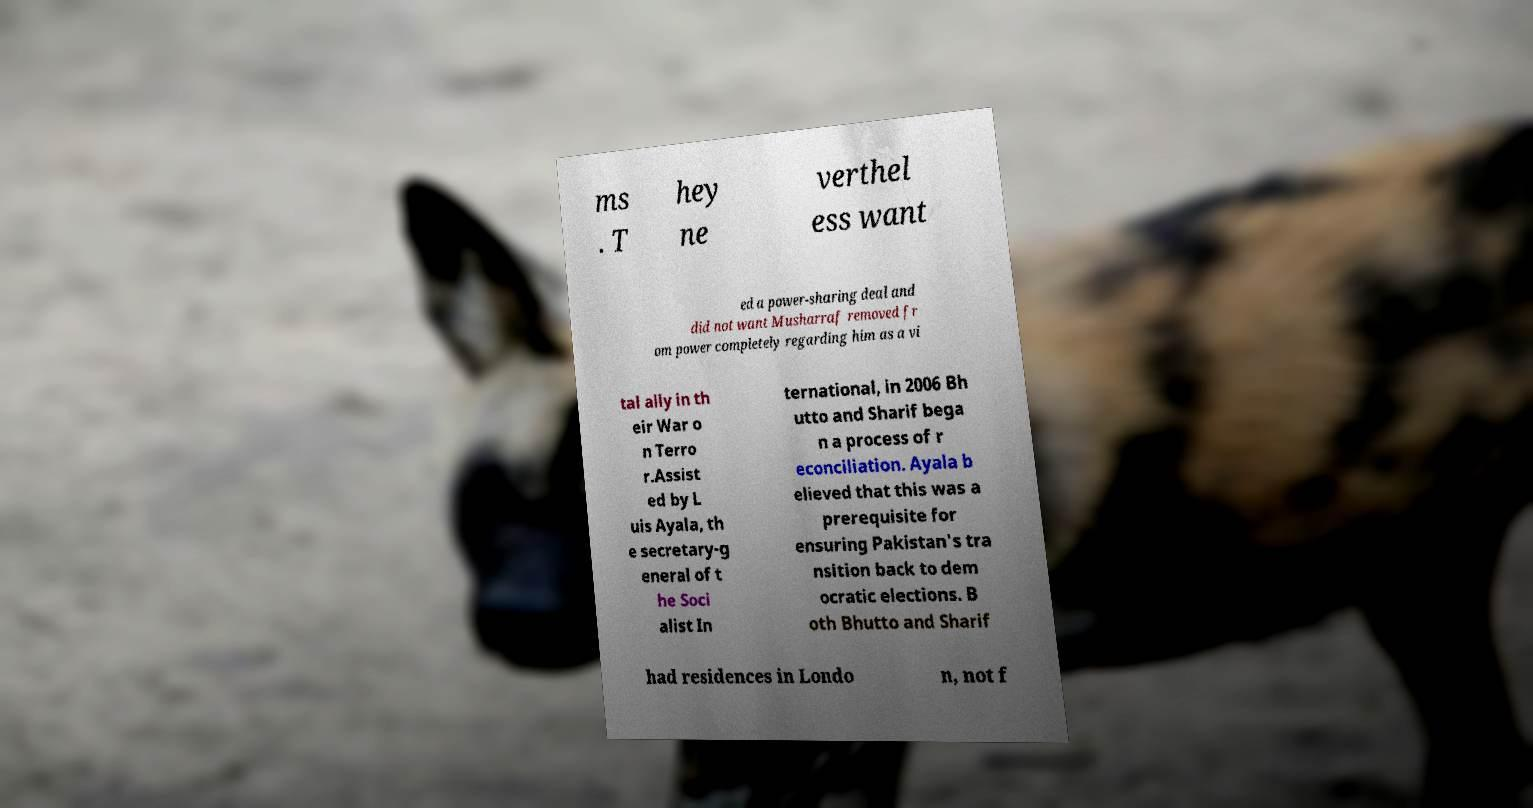For documentation purposes, I need the text within this image transcribed. Could you provide that? ms . T hey ne verthel ess want ed a power-sharing deal and did not want Musharraf removed fr om power completely regarding him as a vi tal ally in th eir War o n Terro r.Assist ed by L uis Ayala, th e secretary-g eneral of t he Soci alist In ternational, in 2006 Bh utto and Sharif bega n a process of r econciliation. Ayala b elieved that this was a prerequisite for ensuring Pakistan's tra nsition back to dem ocratic elections. B oth Bhutto and Sharif had residences in Londo n, not f 